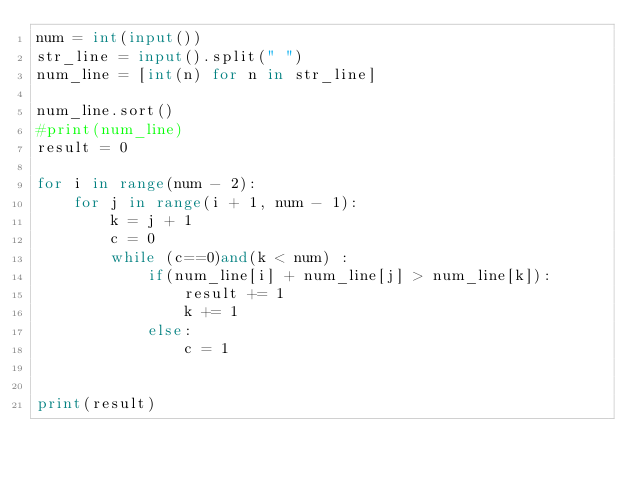<code> <loc_0><loc_0><loc_500><loc_500><_Python_>num = int(input())
str_line = input().split(" ")
num_line = [int(n) for n in str_line]

num_line.sort()
#print(num_line)
result = 0

for i in range(num - 2):
    for j in range(i + 1, num - 1):
        k = j + 1        
        c = 0
        while (c==0)and(k < num) :
            if(num_line[i] + num_line[j] > num_line[k]):
                result += 1
                k += 1
            else:
                c = 1
        
            
print(result)</code> 